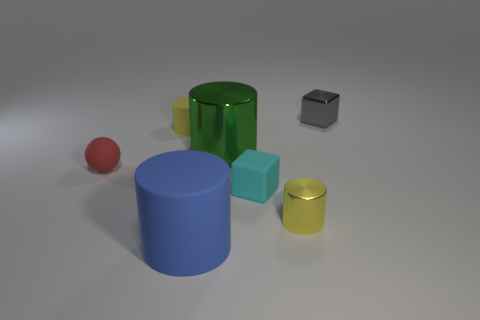Subtract all gray cylinders. Subtract all yellow spheres. How many cylinders are left? 4 Add 3 tiny cubes. How many objects exist? 10 Subtract all cylinders. How many objects are left? 3 Subtract all large blue matte things. Subtract all yellow rubber things. How many objects are left? 5 Add 5 blue cylinders. How many blue cylinders are left? 6 Add 2 cyan rubber cubes. How many cyan rubber cubes exist? 3 Subtract 0 red cubes. How many objects are left? 7 